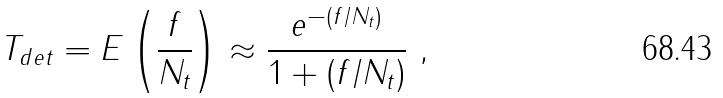Convert formula to latex. <formula><loc_0><loc_0><loc_500><loc_500>T _ { d e t } = E \left ( \frac { f } { N _ { t } } \right ) \approx \frac { e ^ { - ( f / N _ { t } ) } } { 1 + ( f / N _ { t } ) } \ ,</formula> 